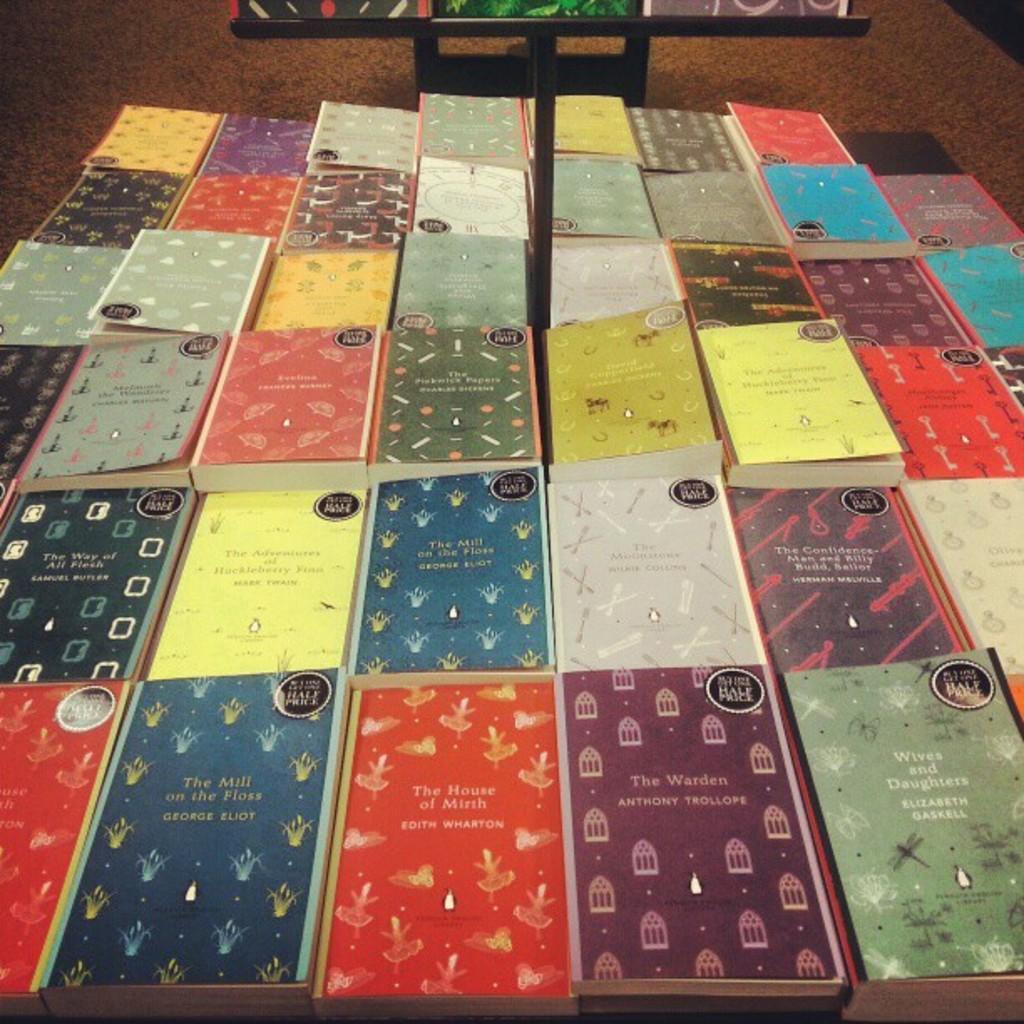Can you describe this image briefly? In the center of the image we can see books placed on the table. 